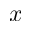Convert formula to latex. <formula><loc_0><loc_0><loc_500><loc_500>x</formula> 